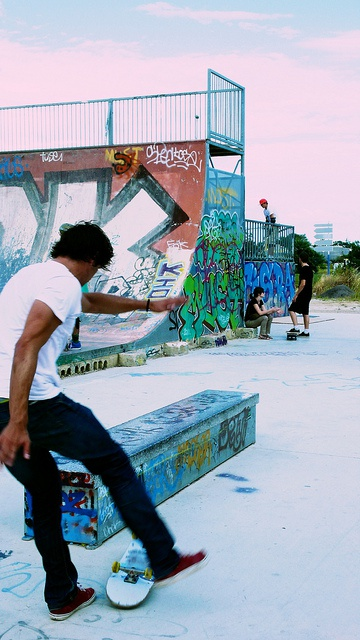Describe the objects in this image and their specific colors. I can see people in lavender, black, maroon, and brown tones, bench in lavender, teal, and lightblue tones, skateboard in lavender, lightblue, black, and teal tones, people in lavender, black, darkgray, and gray tones, and people in lavender, black, gray, darkgray, and darkgreen tones in this image. 